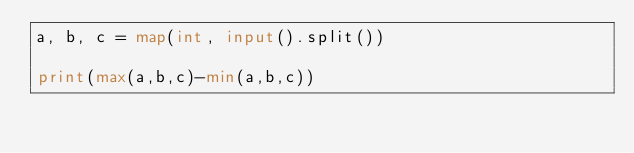<code> <loc_0><loc_0><loc_500><loc_500><_Python_>a, b, c = map(int, input().split())

print(max(a,b,c)-min(a,b,c))</code> 